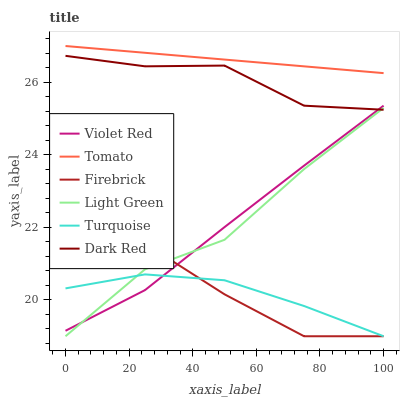Does Turquoise have the minimum area under the curve?
Answer yes or no. Yes. Does Tomato have the maximum area under the curve?
Answer yes or no. Yes. Does Violet Red have the minimum area under the curve?
Answer yes or no. No. Does Violet Red have the maximum area under the curve?
Answer yes or no. No. Is Tomato the smoothest?
Answer yes or no. Yes. Is Dark Red the roughest?
Answer yes or no. Yes. Is Violet Red the smoothest?
Answer yes or no. No. Is Violet Red the roughest?
Answer yes or no. No. Does Firebrick have the lowest value?
Answer yes or no. Yes. Does Violet Red have the lowest value?
Answer yes or no. No. Does Tomato have the highest value?
Answer yes or no. Yes. Does Violet Red have the highest value?
Answer yes or no. No. Is Turquoise less than Tomato?
Answer yes or no. Yes. Is Tomato greater than Turquoise?
Answer yes or no. Yes. Does Turquoise intersect Light Green?
Answer yes or no. Yes. Is Turquoise less than Light Green?
Answer yes or no. No. Is Turquoise greater than Light Green?
Answer yes or no. No. Does Turquoise intersect Tomato?
Answer yes or no. No. 